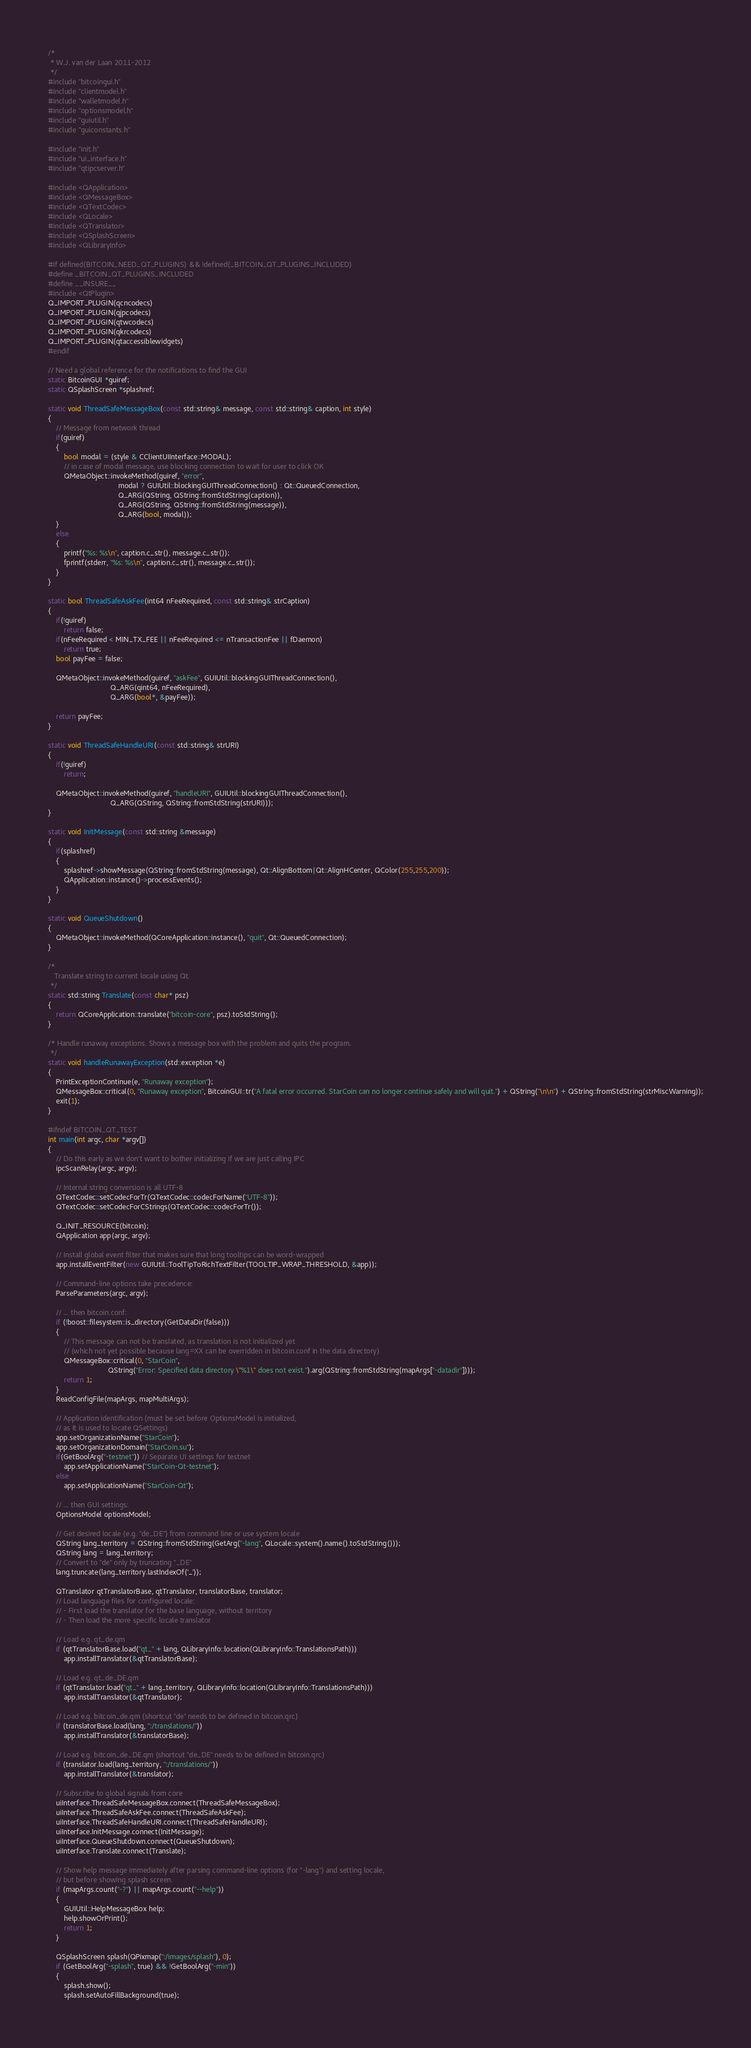Convert code to text. <code><loc_0><loc_0><loc_500><loc_500><_C++_>/*
 * W.J. van der Laan 2011-2012
 */
#include "bitcoingui.h"
#include "clientmodel.h"
#include "walletmodel.h"
#include "optionsmodel.h"
#include "guiutil.h"
#include "guiconstants.h"

#include "init.h"
#include "ui_interface.h"
#include "qtipcserver.h"

#include <QApplication>
#include <QMessageBox>
#include <QTextCodec>
#include <QLocale>
#include <QTranslator>
#include <QSplashScreen>
#include <QLibraryInfo>

#if defined(BITCOIN_NEED_QT_PLUGINS) && !defined(_BITCOIN_QT_PLUGINS_INCLUDED)
#define _BITCOIN_QT_PLUGINS_INCLUDED
#define __INSURE__
#include <QtPlugin>
Q_IMPORT_PLUGIN(qcncodecs)
Q_IMPORT_PLUGIN(qjpcodecs)
Q_IMPORT_PLUGIN(qtwcodecs)
Q_IMPORT_PLUGIN(qkrcodecs)
Q_IMPORT_PLUGIN(qtaccessiblewidgets)
#endif

// Need a global reference for the notifications to find the GUI
static BitcoinGUI *guiref;
static QSplashScreen *splashref;

static void ThreadSafeMessageBox(const std::string& message, const std::string& caption, int style)
{
    // Message from network thread
    if(guiref)
    {
        bool modal = (style & CClientUIInterface::MODAL);
        // in case of modal message, use blocking connection to wait for user to click OK
        QMetaObject::invokeMethod(guiref, "error",
                                   modal ? GUIUtil::blockingGUIThreadConnection() : Qt::QueuedConnection,
                                   Q_ARG(QString, QString::fromStdString(caption)),
                                   Q_ARG(QString, QString::fromStdString(message)),
                                   Q_ARG(bool, modal));
    }
    else
    {
        printf("%s: %s\n", caption.c_str(), message.c_str());
        fprintf(stderr, "%s: %s\n", caption.c_str(), message.c_str());
    }
}

static bool ThreadSafeAskFee(int64 nFeeRequired, const std::string& strCaption)
{
    if(!guiref)
        return false;
    if(nFeeRequired < MIN_TX_FEE || nFeeRequired <= nTransactionFee || fDaemon)
        return true;
    bool payFee = false;

    QMetaObject::invokeMethod(guiref, "askFee", GUIUtil::blockingGUIThreadConnection(),
                               Q_ARG(qint64, nFeeRequired),
                               Q_ARG(bool*, &payFee));

    return payFee;
}

static void ThreadSafeHandleURI(const std::string& strURI)
{
    if(!guiref)
        return;

    QMetaObject::invokeMethod(guiref, "handleURI", GUIUtil::blockingGUIThreadConnection(),
                               Q_ARG(QString, QString::fromStdString(strURI)));
}

static void InitMessage(const std::string &message)
{
    if(splashref)
    {
        splashref->showMessage(QString::fromStdString(message), Qt::AlignBottom|Qt::AlignHCenter, QColor(255,255,200));
        QApplication::instance()->processEvents();
    }
}

static void QueueShutdown()
{
    QMetaObject::invokeMethod(QCoreApplication::instance(), "quit", Qt::QueuedConnection);
}

/*
   Translate string to current locale using Qt.
 */
static std::string Translate(const char* psz)
{
    return QCoreApplication::translate("bitcoin-core", psz).toStdString();
}

/* Handle runaway exceptions. Shows a message box with the problem and quits the program.
 */
static void handleRunawayException(std::exception *e)
{
    PrintExceptionContinue(e, "Runaway exception");
    QMessageBox::critical(0, "Runaway exception", BitcoinGUI::tr("A fatal error occurred. StarCoin can no longer continue safely and will quit.") + QString("\n\n") + QString::fromStdString(strMiscWarning));
    exit(1);
}

#ifndef BITCOIN_QT_TEST
int main(int argc, char *argv[])
{
    // Do this early as we don't want to bother initializing if we are just calling IPC
    ipcScanRelay(argc, argv);

    // Internal string conversion is all UTF-8
    QTextCodec::setCodecForTr(QTextCodec::codecForName("UTF-8"));
    QTextCodec::setCodecForCStrings(QTextCodec::codecForTr());

    Q_INIT_RESOURCE(bitcoin);
    QApplication app(argc, argv);

    // Install global event filter that makes sure that long tooltips can be word-wrapped
    app.installEventFilter(new GUIUtil::ToolTipToRichTextFilter(TOOLTIP_WRAP_THRESHOLD, &app));

    // Command-line options take precedence:
    ParseParameters(argc, argv);

    // ... then bitcoin.conf:
    if (!boost::filesystem::is_directory(GetDataDir(false)))
    {
        // This message can not be translated, as translation is not initialized yet
        // (which not yet possible because lang=XX can be overridden in bitcoin.conf in the data directory)
        QMessageBox::critical(0, "StarCoin",
                              QString("Error: Specified data directory \"%1\" does not exist.").arg(QString::fromStdString(mapArgs["-datadir"])));
        return 1;
    }
    ReadConfigFile(mapArgs, mapMultiArgs);

    // Application identification (must be set before OptionsModel is initialized,
    // as it is used to locate QSettings)
    app.setOrganizationName("StarCoin");
    app.setOrganizationDomain("StarCoin.su");
    if(GetBoolArg("-testnet")) // Separate UI settings for testnet
        app.setApplicationName("StarCoin-Qt-testnet");
    else
        app.setApplicationName("StarCoin-Qt");

    // ... then GUI settings:
    OptionsModel optionsModel;

    // Get desired locale (e.g. "de_DE") from command line or use system locale
    QString lang_territory = QString::fromStdString(GetArg("-lang", QLocale::system().name().toStdString()));
    QString lang = lang_territory;
    // Convert to "de" only by truncating "_DE"
    lang.truncate(lang_territory.lastIndexOf('_'));

    QTranslator qtTranslatorBase, qtTranslator, translatorBase, translator;
    // Load language files for configured locale:
    // - First load the translator for the base language, without territory
    // - Then load the more specific locale translator

    // Load e.g. qt_de.qm
    if (qtTranslatorBase.load("qt_" + lang, QLibraryInfo::location(QLibraryInfo::TranslationsPath)))
        app.installTranslator(&qtTranslatorBase);

    // Load e.g. qt_de_DE.qm
    if (qtTranslator.load("qt_" + lang_territory, QLibraryInfo::location(QLibraryInfo::TranslationsPath)))
        app.installTranslator(&qtTranslator);

    // Load e.g. bitcoin_de.qm (shortcut "de" needs to be defined in bitcoin.qrc)
    if (translatorBase.load(lang, ":/translations/"))
        app.installTranslator(&translatorBase);

    // Load e.g. bitcoin_de_DE.qm (shortcut "de_DE" needs to be defined in bitcoin.qrc)
    if (translator.load(lang_territory, ":/translations/"))
        app.installTranslator(&translator);

    // Subscribe to global signals from core
    uiInterface.ThreadSafeMessageBox.connect(ThreadSafeMessageBox);
    uiInterface.ThreadSafeAskFee.connect(ThreadSafeAskFee);
    uiInterface.ThreadSafeHandleURI.connect(ThreadSafeHandleURI);
    uiInterface.InitMessage.connect(InitMessage);
    uiInterface.QueueShutdown.connect(QueueShutdown);
    uiInterface.Translate.connect(Translate);

    // Show help message immediately after parsing command-line options (for "-lang") and setting locale,
    // but before showing splash screen.
    if (mapArgs.count("-?") || mapArgs.count("--help"))
    {
        GUIUtil::HelpMessageBox help;
        help.showOrPrint();
        return 1;
    }

    QSplashScreen splash(QPixmap(":/images/splash"), 0);
    if (GetBoolArg("-splash", true) && !GetBoolArg("-min"))
    {
        splash.show();
        splash.setAutoFillBackground(true);</code> 